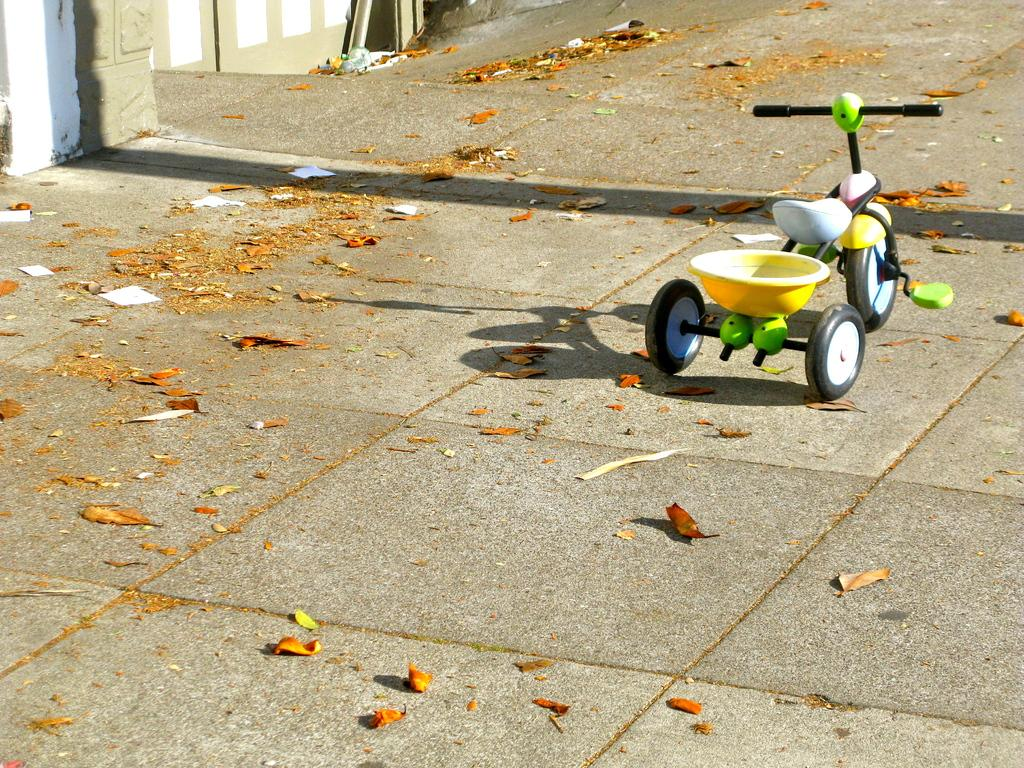What type of toy can be seen on the right side of the image? There is a toy vehicle on the right side of the image. Where is the toy vehicle located? The toy vehicle is on the road. Can you describe the condition of the toy vehicle? There is dust on the toy vehicle. What can be seen in the background of the image? There is a wall visible in the background of the image. What type of arithmetic problem is the judge solving in the image? There is no judge or arithmetic problem present in the image; it features a toy vehicle on the road with dust on it and a wall in the background. Is there a hill visible in the image? There is no hill visible in the image; it only shows a toy vehicle on the road, dust on the toy vehicle, and a wall in the background. 